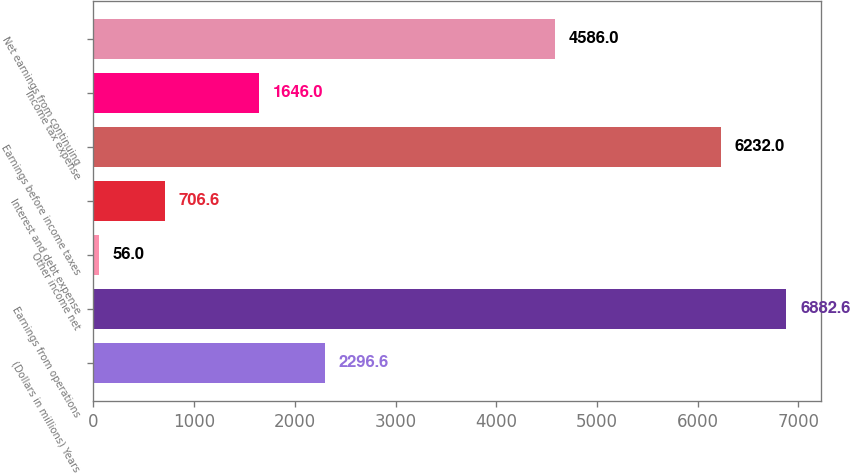Convert chart. <chart><loc_0><loc_0><loc_500><loc_500><bar_chart><fcel>(Dollars in millions) Years<fcel>Earnings from operations<fcel>Other income net<fcel>Interest and debt expense<fcel>Earnings before income taxes<fcel>Income tax expense<fcel>Net earnings from continuing<nl><fcel>2296.6<fcel>6882.6<fcel>56<fcel>706.6<fcel>6232<fcel>1646<fcel>4586<nl></chart> 